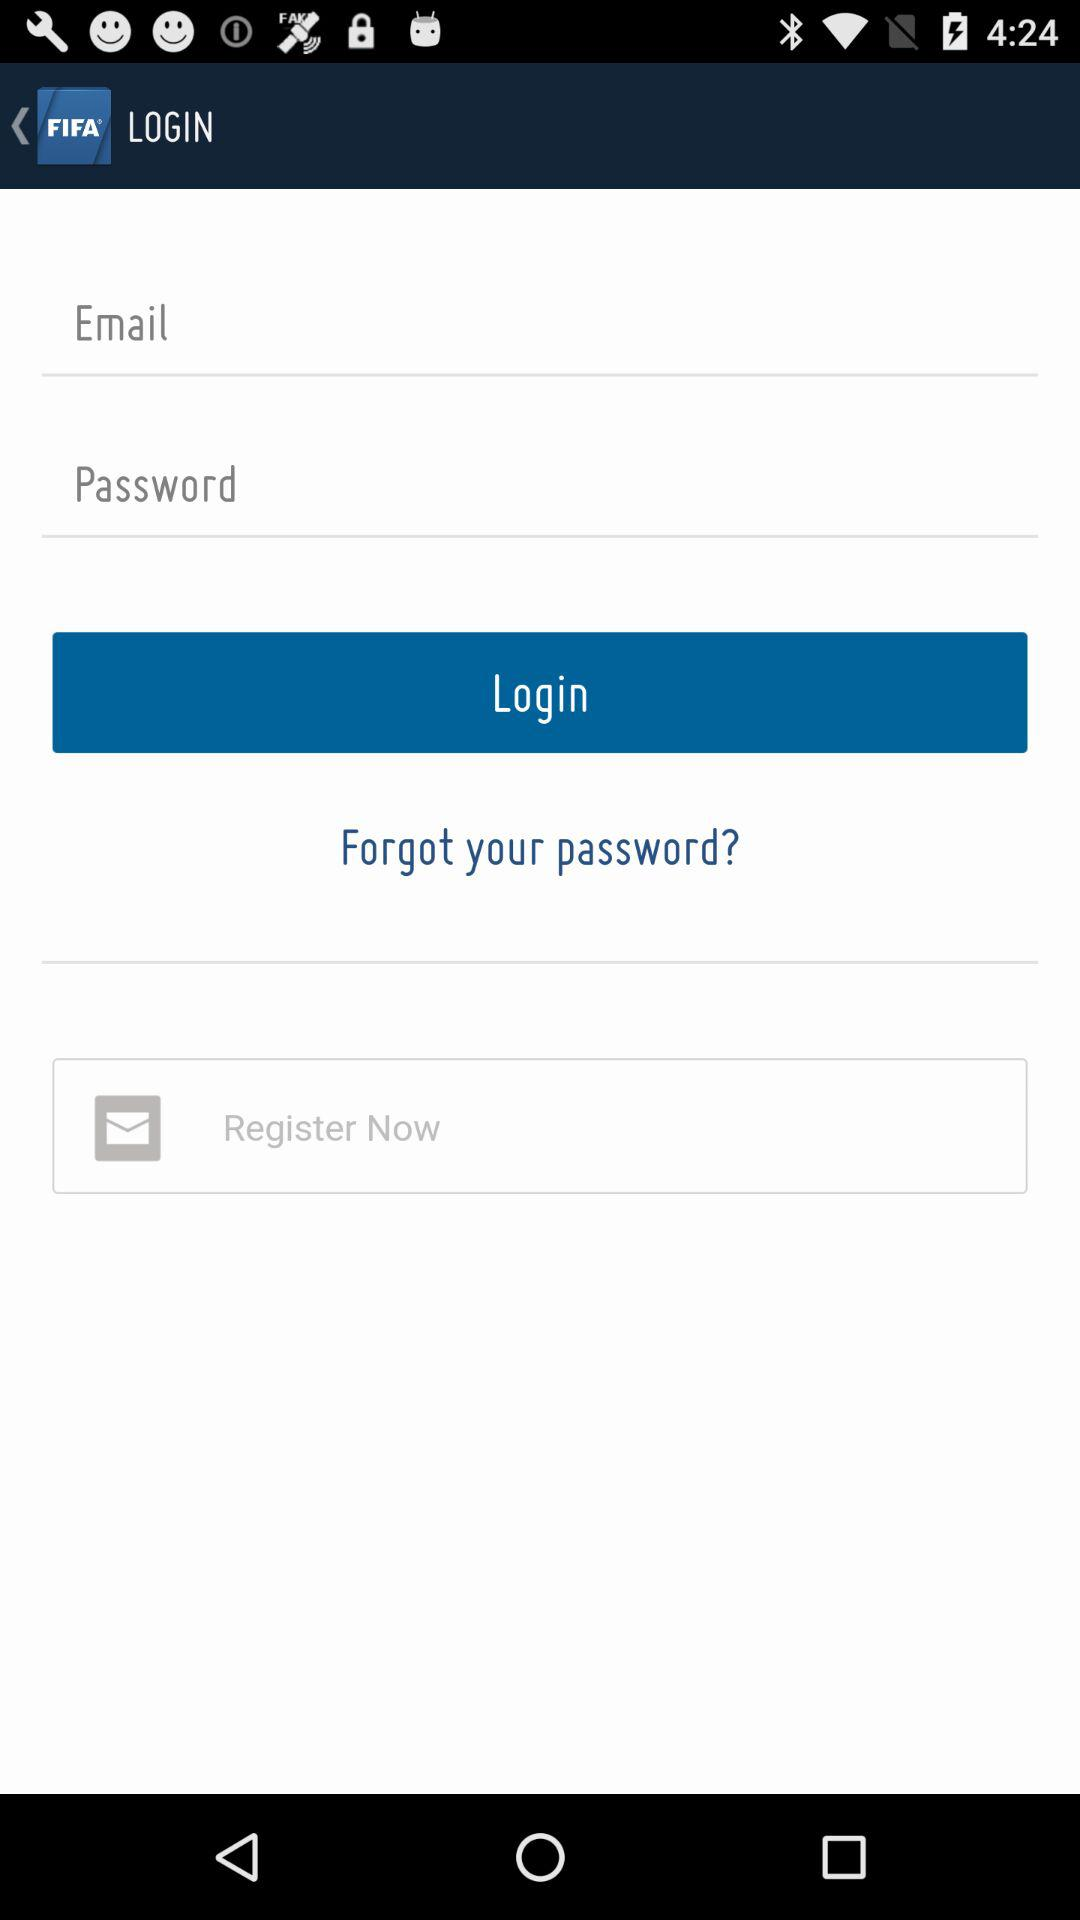How many text inputs are there for entering information?
Answer the question using a single word or phrase. 2 